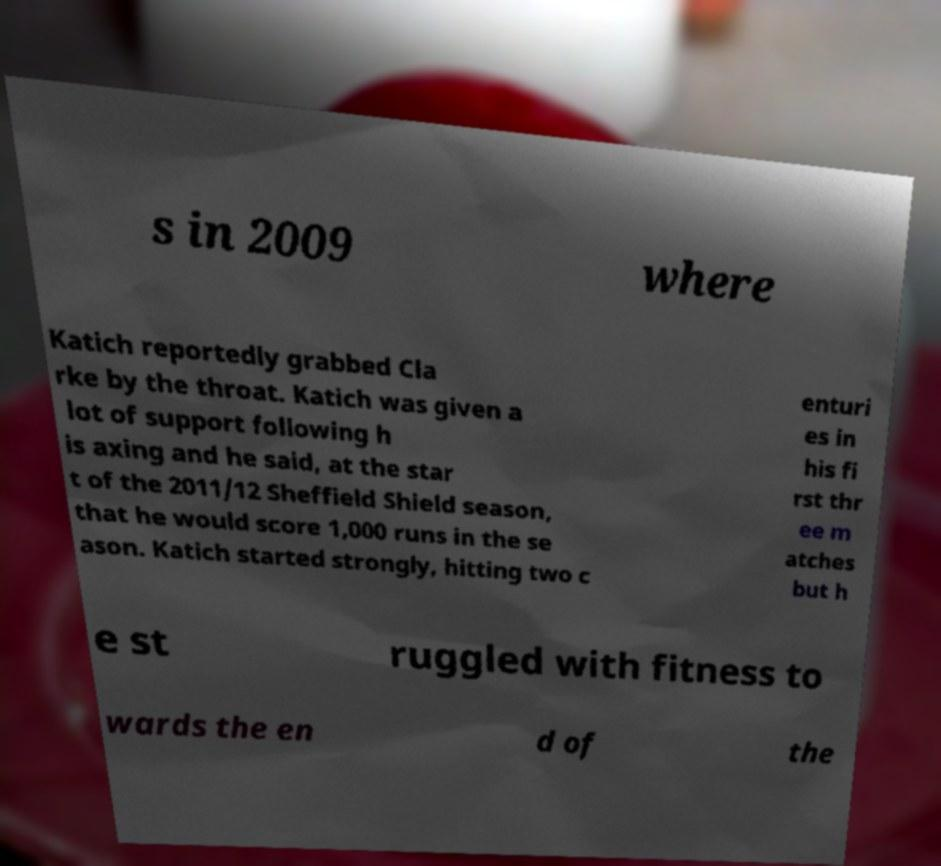Could you extract and type out the text from this image? s in 2009 where Katich reportedly grabbed Cla rke by the throat. Katich was given a lot of support following h is axing and he said, at the star t of the 2011/12 Sheffield Shield season, that he would score 1,000 runs in the se ason. Katich started strongly, hitting two c enturi es in his fi rst thr ee m atches but h e st ruggled with fitness to wards the en d of the 